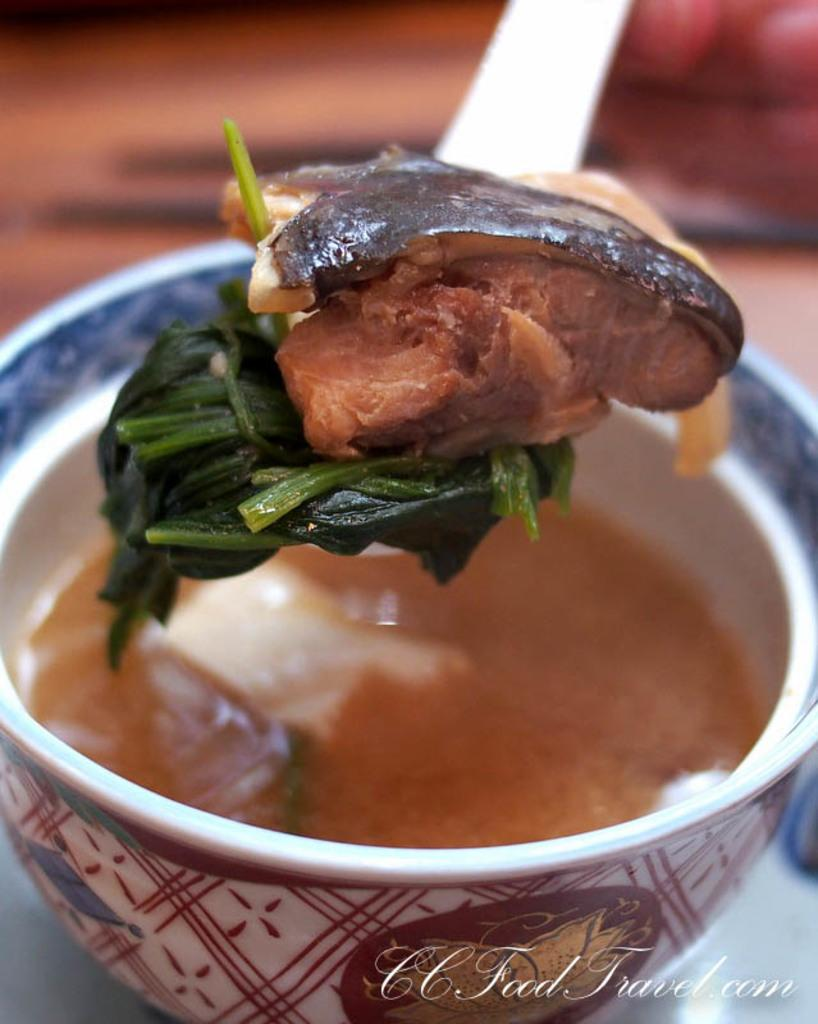What is present in the image that can hold food? There is a bowl in the image that can hold food. What type of food item is in the bowl? There is a food item in the bowl, but the specific type is not mentioned in the facts. What utensil is visible in the image? There is a spoon in the image. What is on the spoon? There is a food item on the spoon. Can you describe the background of the image? The background of the image is blurred. How many dolls are on the boat in the image? There is no boat or dolls present in the image. What direction are the dolls facing on the boat in the image? Since there are no dolls or boat in the image, we cannot determine the direction they might be facing. 